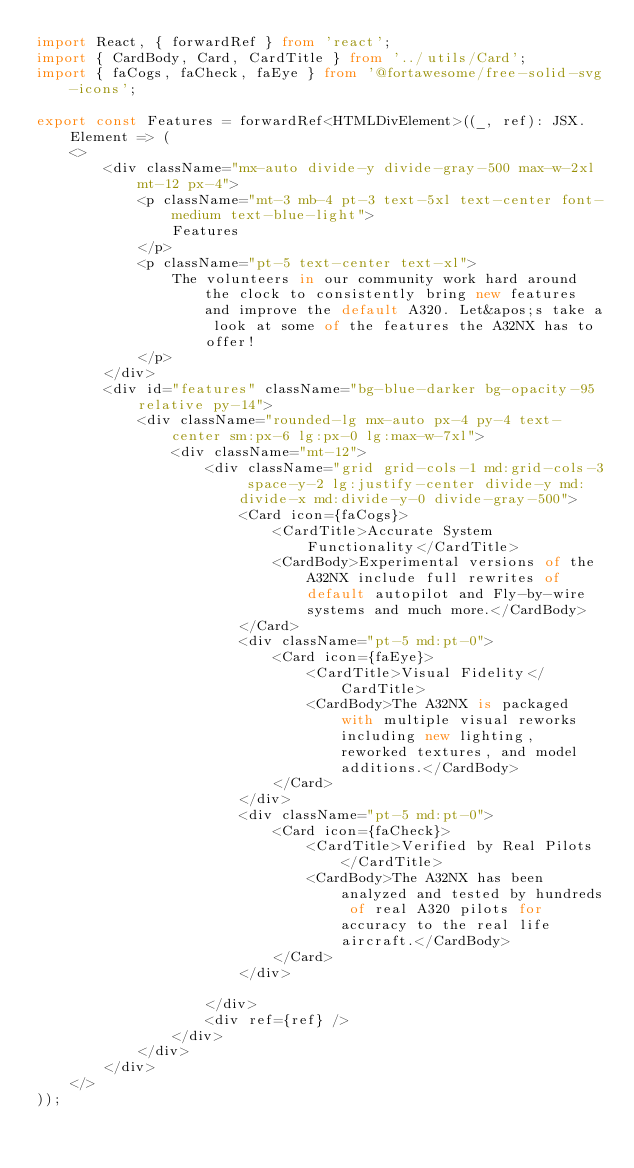Convert code to text. <code><loc_0><loc_0><loc_500><loc_500><_TypeScript_>import React, { forwardRef } from 'react';
import { CardBody, Card, CardTitle } from '../utils/Card';
import { faCogs, faCheck, faEye } from '@fortawesome/free-solid-svg-icons';

export const Features = forwardRef<HTMLDivElement>((_, ref): JSX.Element => (
    <>
        <div className="mx-auto divide-y divide-gray-500 max-w-2xl mt-12 px-4">
            <p className="mt-3 mb-4 pt-3 text-5xl text-center font-medium text-blue-light">
                Features
            </p>
            <p className="pt-5 text-center text-xl">
                The volunteers in our community work hard around the clock to consistently bring new features and improve the default A320. Let&apos;s take a look at some of the features the A32NX has to offer!
            </p>
        </div>
        <div id="features" className="bg-blue-darker bg-opacity-95 relative py-14">
            <div className="rounded-lg mx-auto px-4 py-4 text-center sm:px-6 lg:px-0 lg:max-w-7xl">
                <div className="mt-12">
                    <div className="grid grid-cols-1 md:grid-cols-3 space-y-2 lg:justify-center divide-y md:divide-x md:divide-y-0 divide-gray-500">
                        <Card icon={faCogs}>
                            <CardTitle>Accurate System Functionality</CardTitle>
                            <CardBody>Experimental versions of the A32NX include full rewrites of default autopilot and Fly-by-wire systems and much more.</CardBody>
                        </Card>
                        <div className="pt-5 md:pt-0">
                            <Card icon={faEye}>
                                <CardTitle>Visual Fidelity</CardTitle>
                                <CardBody>The A32NX is packaged with multiple visual reworks including new lighting, reworked textures, and model additions.</CardBody>
                            </Card>
                        </div>
                        <div className="pt-5 md:pt-0">
                            <Card icon={faCheck}>
                                <CardTitle>Verified by Real Pilots</CardTitle>
                                <CardBody>The A32NX has been analyzed and tested by hundreds of real A320 pilots for accuracy to the real life aircraft.</CardBody>
                            </Card>
                        </div>

                    </div>
                    <div ref={ref} />
                </div>
            </div>
        </div>
    </>
));
</code> 